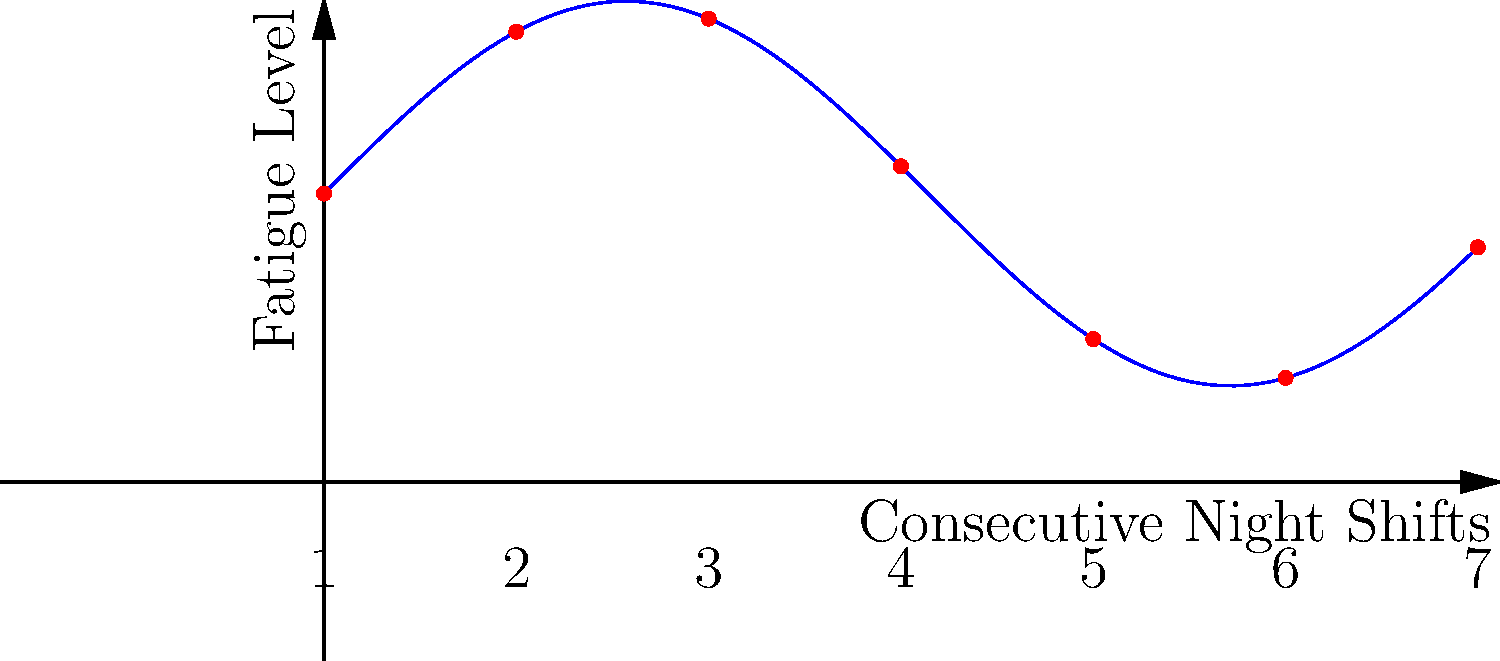The graph shows fatigue levels of officers during a series of consecutive night shifts. If the trend continues, what will be the approximate difference in fatigue levels between the 7th and 3rd night shifts? To solve this problem, we need to follow these steps:

1. Identify the fatigue levels for the 3rd and 7th night shifts:
   - 3rd shift (x = 4): Fatigue level ≈ 4
   - 7th shift (x = 12): Fatigue level ≈ 5

2. Calculate the difference:
   $$ \text{Difference} = \text{Fatigue level (7th shift)} - \text{Fatigue level (3rd shift)} $$
   $$ \text{Difference} \approx 5 - 4 = 1 $$

The approximate difference in fatigue levels between the 7th and 3rd night shifts is 1 unit.

This analysis is crucial for understanding the cumulative effects of night shifts on officer fatigue, which is essential for maintaining officer safety and effectiveness in law enforcement operations.
Answer: 1 unit 